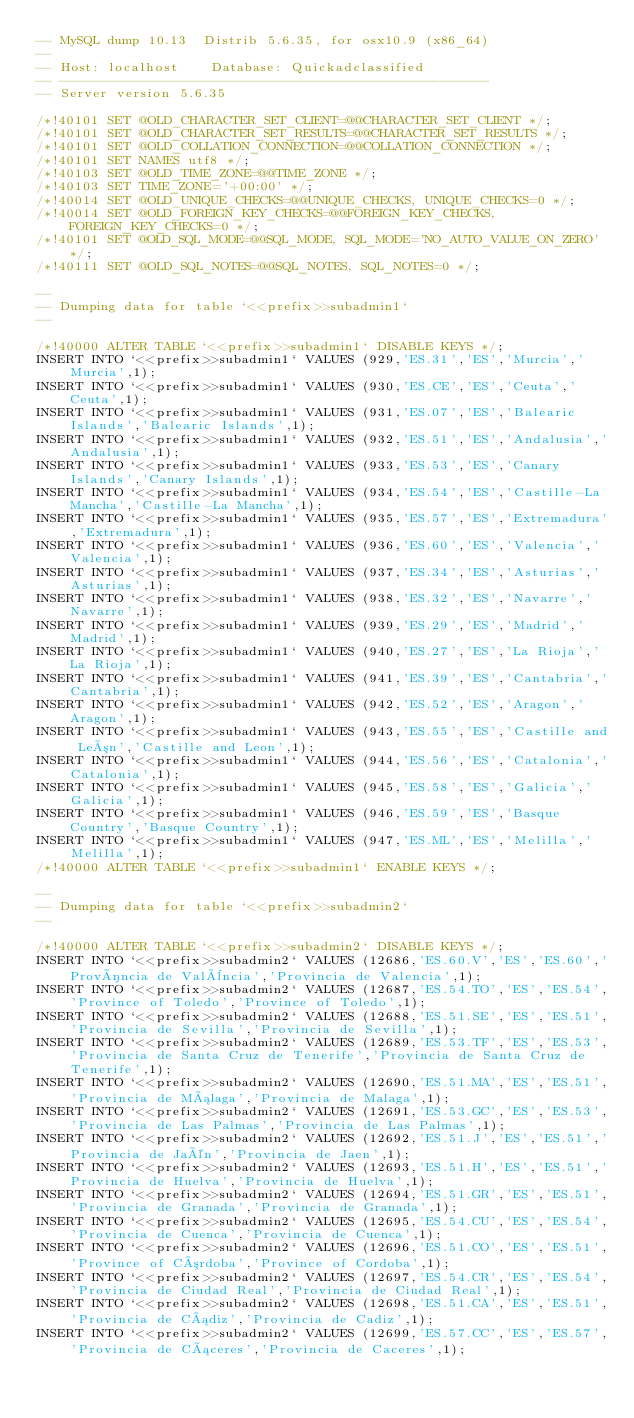Convert code to text. <code><loc_0><loc_0><loc_500><loc_500><_SQL_>-- MySQL dump 10.13  Distrib 5.6.35, for osx10.9 (x86_64)
--
-- Host: localhost    Database: Quickadclassified
-- ------------------------------------------------------
-- Server version	5.6.35

/*!40101 SET @OLD_CHARACTER_SET_CLIENT=@@CHARACTER_SET_CLIENT */;
/*!40101 SET @OLD_CHARACTER_SET_RESULTS=@@CHARACTER_SET_RESULTS */;
/*!40101 SET @OLD_COLLATION_CONNECTION=@@COLLATION_CONNECTION */;
/*!40101 SET NAMES utf8 */;
/*!40103 SET @OLD_TIME_ZONE=@@TIME_ZONE */;
/*!40103 SET TIME_ZONE='+00:00' */;
/*!40014 SET @OLD_UNIQUE_CHECKS=@@UNIQUE_CHECKS, UNIQUE_CHECKS=0 */;
/*!40014 SET @OLD_FOREIGN_KEY_CHECKS=@@FOREIGN_KEY_CHECKS, FOREIGN_KEY_CHECKS=0 */;
/*!40101 SET @OLD_SQL_MODE=@@SQL_MODE, SQL_MODE='NO_AUTO_VALUE_ON_ZERO' */;
/*!40111 SET @OLD_SQL_NOTES=@@SQL_NOTES, SQL_NOTES=0 */;

--
-- Dumping data for table `<<prefix>>subadmin1`
--

/*!40000 ALTER TABLE `<<prefix>>subadmin1` DISABLE KEYS */;
INSERT INTO `<<prefix>>subadmin1` VALUES (929,'ES.31','ES','Murcia','Murcia',1);
INSERT INTO `<<prefix>>subadmin1` VALUES (930,'ES.CE','ES','Ceuta','Ceuta',1);
INSERT INTO `<<prefix>>subadmin1` VALUES (931,'ES.07','ES','Balearic Islands','Balearic Islands',1);
INSERT INTO `<<prefix>>subadmin1` VALUES (932,'ES.51','ES','Andalusia','Andalusia',1);
INSERT INTO `<<prefix>>subadmin1` VALUES (933,'ES.53','ES','Canary Islands','Canary Islands',1);
INSERT INTO `<<prefix>>subadmin1` VALUES (934,'ES.54','ES','Castille-La Mancha','Castille-La Mancha',1);
INSERT INTO `<<prefix>>subadmin1` VALUES (935,'ES.57','ES','Extremadura','Extremadura',1);
INSERT INTO `<<prefix>>subadmin1` VALUES (936,'ES.60','ES','Valencia','Valencia',1);
INSERT INTO `<<prefix>>subadmin1` VALUES (937,'ES.34','ES','Asturias','Asturias',1);
INSERT INTO `<<prefix>>subadmin1` VALUES (938,'ES.32','ES','Navarre','Navarre',1);
INSERT INTO `<<prefix>>subadmin1` VALUES (939,'ES.29','ES','Madrid','Madrid',1);
INSERT INTO `<<prefix>>subadmin1` VALUES (940,'ES.27','ES','La Rioja','La Rioja',1);
INSERT INTO `<<prefix>>subadmin1` VALUES (941,'ES.39','ES','Cantabria','Cantabria',1);
INSERT INTO `<<prefix>>subadmin1` VALUES (942,'ES.52','ES','Aragon','Aragon',1);
INSERT INTO `<<prefix>>subadmin1` VALUES (943,'ES.55','ES','Castille and León','Castille and Leon',1);
INSERT INTO `<<prefix>>subadmin1` VALUES (944,'ES.56','ES','Catalonia','Catalonia',1);
INSERT INTO `<<prefix>>subadmin1` VALUES (945,'ES.58','ES','Galicia','Galicia',1);
INSERT INTO `<<prefix>>subadmin1` VALUES (946,'ES.59','ES','Basque Country','Basque Country',1);
INSERT INTO `<<prefix>>subadmin1` VALUES (947,'ES.ML','ES','Melilla','Melilla',1);
/*!40000 ALTER TABLE `<<prefix>>subadmin1` ENABLE KEYS */;

--
-- Dumping data for table `<<prefix>>subadmin2`
--

/*!40000 ALTER TABLE `<<prefix>>subadmin2` DISABLE KEYS */;
INSERT INTO `<<prefix>>subadmin2` VALUES (12686,'ES.60.V','ES','ES.60','Província de València','Provincia de Valencia',1);
INSERT INTO `<<prefix>>subadmin2` VALUES (12687,'ES.54.TO','ES','ES.54','Province of Toledo','Province of Toledo',1);
INSERT INTO `<<prefix>>subadmin2` VALUES (12688,'ES.51.SE','ES','ES.51','Provincia de Sevilla','Provincia de Sevilla',1);
INSERT INTO `<<prefix>>subadmin2` VALUES (12689,'ES.53.TF','ES','ES.53','Provincia de Santa Cruz de Tenerife','Provincia de Santa Cruz de Tenerife',1);
INSERT INTO `<<prefix>>subadmin2` VALUES (12690,'ES.51.MA','ES','ES.51','Provincia de Málaga','Provincia de Malaga',1);
INSERT INTO `<<prefix>>subadmin2` VALUES (12691,'ES.53.GC','ES','ES.53','Provincia de Las Palmas','Provincia de Las Palmas',1);
INSERT INTO `<<prefix>>subadmin2` VALUES (12692,'ES.51.J','ES','ES.51','Provincia de Jaén','Provincia de Jaen',1);
INSERT INTO `<<prefix>>subadmin2` VALUES (12693,'ES.51.H','ES','ES.51','Provincia de Huelva','Provincia de Huelva',1);
INSERT INTO `<<prefix>>subadmin2` VALUES (12694,'ES.51.GR','ES','ES.51','Provincia de Granada','Provincia de Granada',1);
INSERT INTO `<<prefix>>subadmin2` VALUES (12695,'ES.54.CU','ES','ES.54','Provincia de Cuenca','Provincia de Cuenca',1);
INSERT INTO `<<prefix>>subadmin2` VALUES (12696,'ES.51.CO','ES','ES.51','Province of Córdoba','Province of Cordoba',1);
INSERT INTO `<<prefix>>subadmin2` VALUES (12697,'ES.54.CR','ES','ES.54','Provincia de Ciudad Real','Provincia de Ciudad Real',1);
INSERT INTO `<<prefix>>subadmin2` VALUES (12698,'ES.51.CA','ES','ES.51','Provincia de Cádiz','Provincia de Cadiz',1);
INSERT INTO `<<prefix>>subadmin2` VALUES (12699,'ES.57.CC','ES','ES.57','Provincia de Cáceres','Provincia de Caceres',1);</code> 